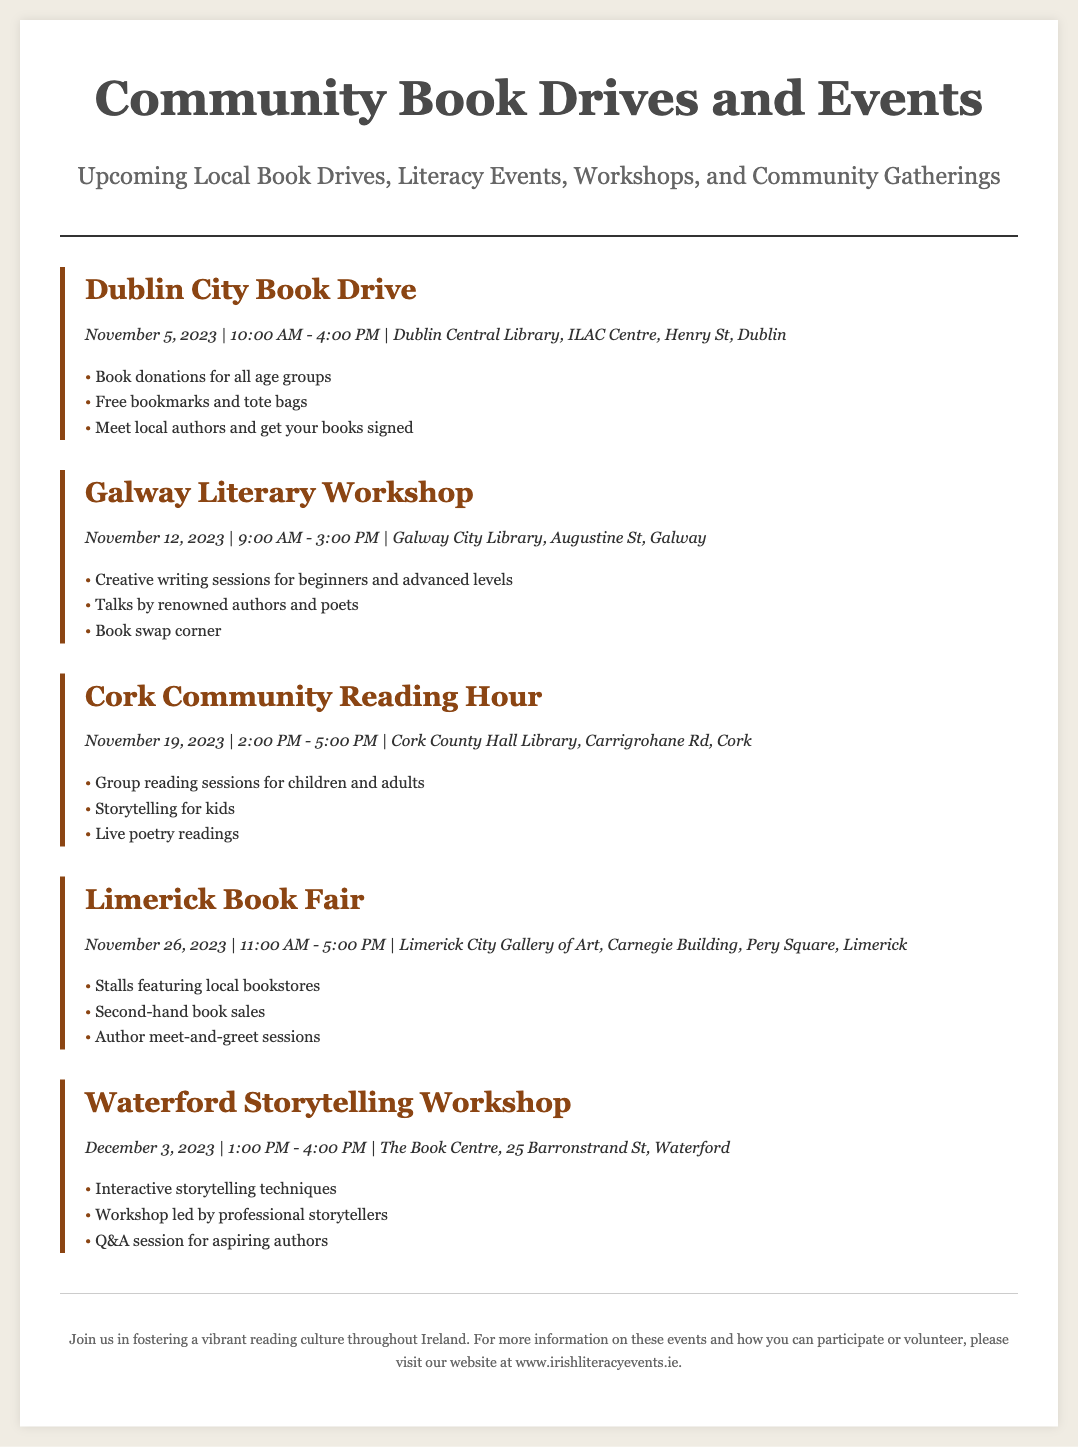What is the date of the Dublin City Book Drive? The date of the Dublin City Book Drive is specified as November 5, 2023.
Answer: November 5, 2023 Where is the Galway Literary Workshop being held? The location of the Galway Literary Workshop is mentioned as Galway City Library, Augustine St, Galway.
Answer: Galway City Library, Augustine St, Galway What time does the Cork Community Reading Hour start? The starting time for the Cork Community Reading Hour is indicated as 2:00 PM.
Answer: 2:00 PM What types of sessions are offered at the Waterford Storytelling Workshop? The types of sessions offered at the Waterford Storytelling Workshop include interactive storytelling techniques and a Q&A session.
Answer: Interactive storytelling techniques and Q&A session Which event features second-hand book sales? The event that features second-hand book sales is the Limerick Book Fair.
Answer: Limerick Book Fair How many events are listed in the document? The total number of events listed in the document is derived from the number of event sections, which is five.
Answer: Five What unique activity is included in the Cork Community Reading Hour? The unique activity included in the Cork Community Reading Hour is storytelling for kids.
Answer: Storytelling for kids Which event includes a book swap corner? The event that includes a book swap corner is the Galway Literary Workshop.
Answer: Galway Literary Workshop What common theme do all events share? The common theme shared by all events is promoting reading culture.
Answer: Promoting reading culture 